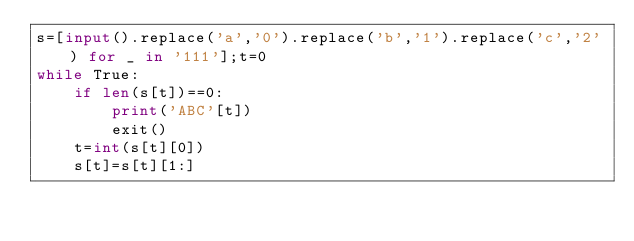Convert code to text. <code><loc_0><loc_0><loc_500><loc_500><_Python_>s=[input().replace('a','0').replace('b','1').replace('c','2') for _ in '111'];t=0
while True:
	if len(s[t])==0:
		print('ABC'[t])
		exit()
	t=int(s[t][0])
	s[t]=s[t][1:]</code> 